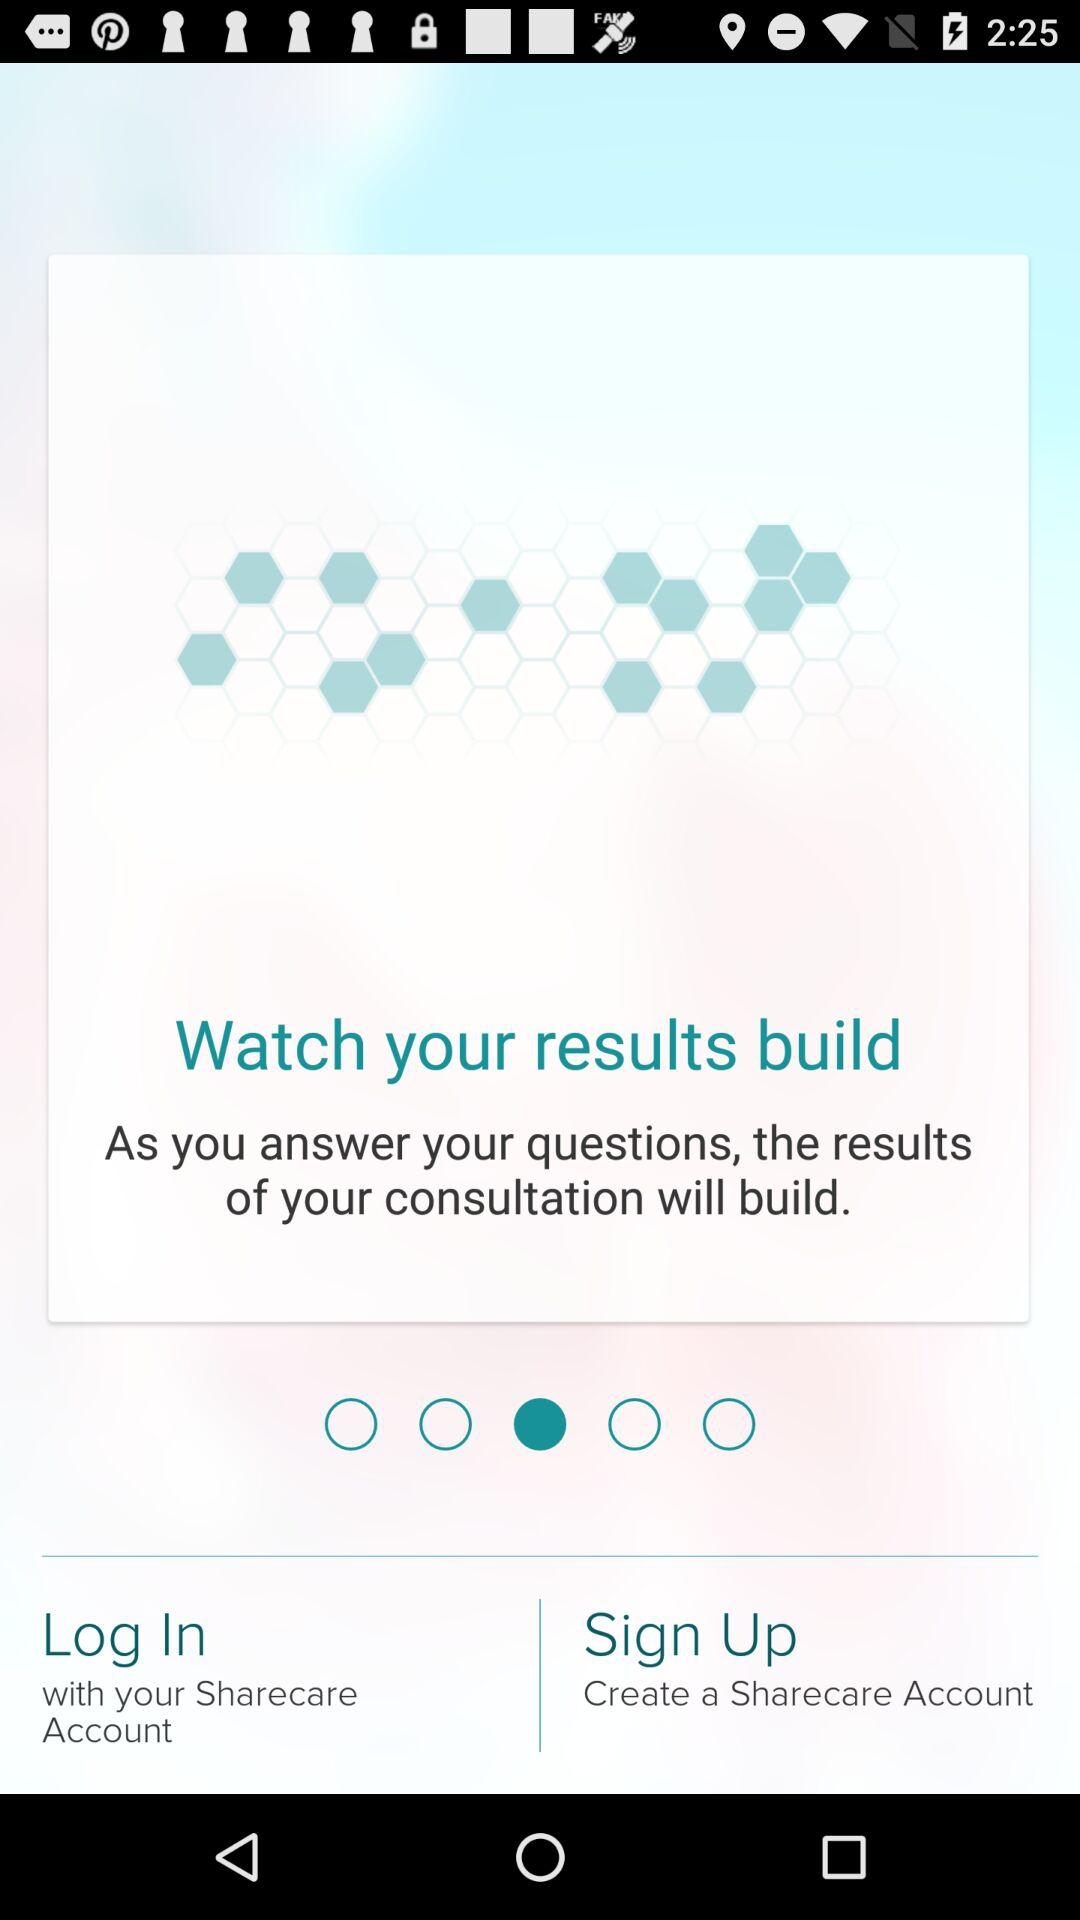What is the app name? The app name is "Sharecare". 